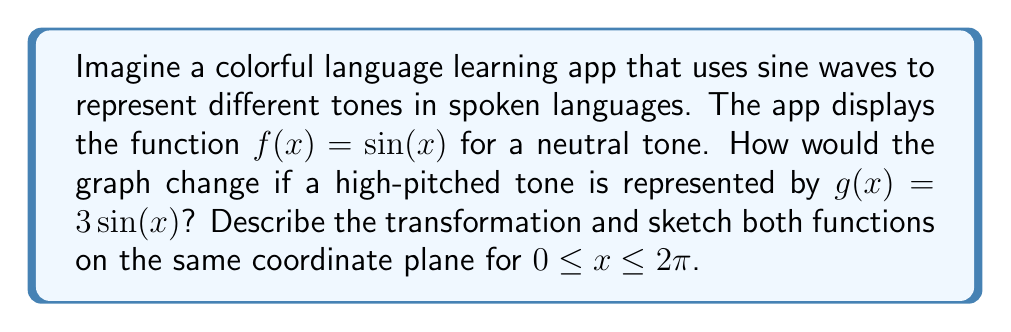What is the answer to this math problem? To understand the transformation from $f(x) = \sin(x)$ to $g(x) = 3\sin(x)$, let's follow these steps:

1) The original function $f(x) = \sin(x)$ has an amplitude of 1, meaning it oscillates between -1 and 1 on the y-axis.

2) In $g(x) = 3\sin(x)$, we're multiplying the entire $\sin(x)$ function by 3. This is a vertical stretch by a factor of 3.

3) The effect of this transformation:
   - The amplitude increases from 1 to 3
   - The function will now oscillate between -3 and 3 on the y-axis
   - The period remains unchanged at $2\pi$
   - The x-intercepts remain the same (at $x = 0, \pi, 2\pi$)

4) Visually, the graph will appear taller but with the same width as the original sine function.

Here's a sketch of both functions:

[asy]
import graph;
size(200,200);
real f(real x) {return sin(x);}
real g(real x) {return 3*sin(x);}

draw(graph(f,0,2*pi),blue);
draw(graph(g,0,2*pi),red);

xaxis("x",Arrow);
yaxis("y",Arrow);

label("f(x) = sin(x)",(-0.5,0.5),blue);
label("g(x) = 3sin(x)",(-0.5,2.5),red);
[/asy]

The blue curve represents $f(x) = \sin(x)$, and the red curve represents $g(x) = 3\sin(x)$.
Answer: Vertical stretch by factor of 3; amplitude increases from 1 to 3. 